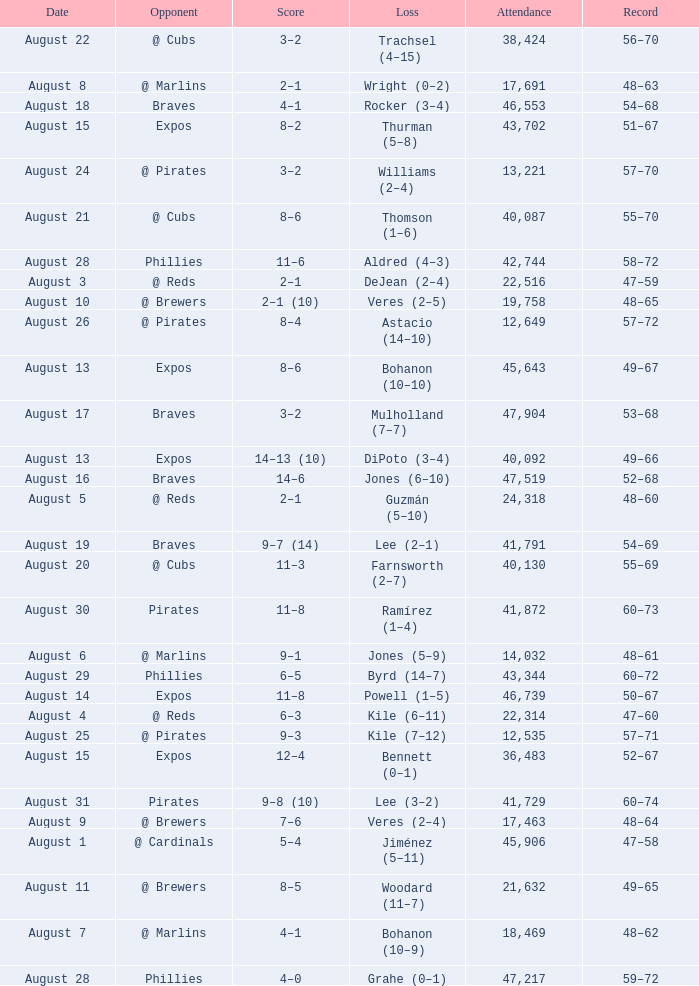Help me parse the entirety of this table. {'header': ['Date', 'Opponent', 'Score', 'Loss', 'Attendance', 'Record'], 'rows': [['August 22', '@ Cubs', '3–2', 'Trachsel (4–15)', '38,424', '56–70'], ['August 8', '@ Marlins', '2–1', 'Wright (0–2)', '17,691', '48–63'], ['August 18', 'Braves', '4–1', 'Rocker (3–4)', '46,553', '54–68'], ['August 15', 'Expos', '8–2', 'Thurman (5–8)', '43,702', '51–67'], ['August 24', '@ Pirates', '3–2', 'Williams (2–4)', '13,221', '57–70'], ['August 21', '@ Cubs', '8–6', 'Thomson (1–6)', '40,087', '55–70'], ['August 28', 'Phillies', '11–6', 'Aldred (4–3)', '42,744', '58–72'], ['August 3', '@ Reds', '2–1', 'DeJean (2–4)', '22,516', '47–59'], ['August 10', '@ Brewers', '2–1 (10)', 'Veres (2–5)', '19,758', '48–65'], ['August 26', '@ Pirates', '8–4', 'Astacio (14–10)', '12,649', '57–72'], ['August 13', 'Expos', '8–6', 'Bohanon (10–10)', '45,643', '49–67'], ['August 17', 'Braves', '3–2', 'Mulholland (7–7)', '47,904', '53–68'], ['August 13', 'Expos', '14–13 (10)', 'DiPoto (3–4)', '40,092', '49–66'], ['August 16', 'Braves', '14–6', 'Jones (6–10)', '47,519', '52–68'], ['August 5', '@ Reds', '2–1', 'Guzmán (5–10)', '24,318', '48–60'], ['August 19', 'Braves', '9–7 (14)', 'Lee (2–1)', '41,791', '54–69'], ['August 20', '@ Cubs', '11–3', 'Farnsworth (2–7)', '40,130', '55–69'], ['August 30', 'Pirates', '11–8', 'Ramírez (1–4)', '41,872', '60–73'], ['August 6', '@ Marlins', '9–1', 'Jones (5–9)', '14,032', '48–61'], ['August 29', 'Phillies', '6–5', 'Byrd (14–7)', '43,344', '60–72'], ['August 14', 'Expos', '11–8', 'Powell (1–5)', '46,739', '50–67'], ['August 4', '@ Reds', '6–3', 'Kile (6–11)', '22,314', '47–60'], ['August 25', '@ Pirates', '9–3', 'Kile (7–12)', '12,535', '57–71'], ['August 15', 'Expos', '12–4', 'Bennett (0–1)', '36,483', '52–67'], ['August 31', 'Pirates', '9–8 (10)', 'Lee (3–2)', '41,729', '60–74'], ['August 9', '@ Brewers', '7–6', 'Veres (2–4)', '17,463', '48–64'], ['August 1', '@ Cardinals', '5–4', 'Jiménez (5–11)', '45,906', '47–58'], ['August 11', '@ Brewers', '8–5', 'Woodard (11–7)', '21,632', '49–65'], ['August 7', '@ Marlins', '4–1', 'Bohanon (10–9)', '18,469', '48–62'], ['August 28', 'Phillies', '4–0', 'Grahe (0–1)', '47,217', '59–72']]} What is the lowest attendance total on August 26? 12649.0. 